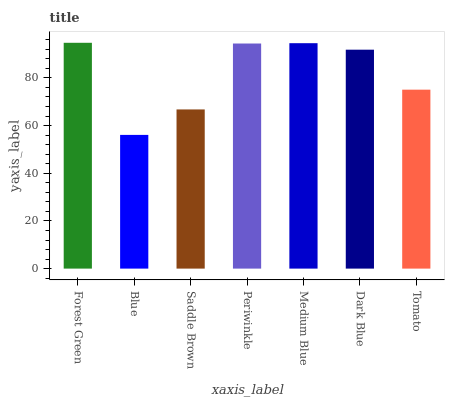Is Blue the minimum?
Answer yes or no. Yes. Is Forest Green the maximum?
Answer yes or no. Yes. Is Saddle Brown the minimum?
Answer yes or no. No. Is Saddle Brown the maximum?
Answer yes or no. No. Is Saddle Brown greater than Blue?
Answer yes or no. Yes. Is Blue less than Saddle Brown?
Answer yes or no. Yes. Is Blue greater than Saddle Brown?
Answer yes or no. No. Is Saddle Brown less than Blue?
Answer yes or no. No. Is Dark Blue the high median?
Answer yes or no. Yes. Is Dark Blue the low median?
Answer yes or no. Yes. Is Saddle Brown the high median?
Answer yes or no. No. Is Medium Blue the low median?
Answer yes or no. No. 